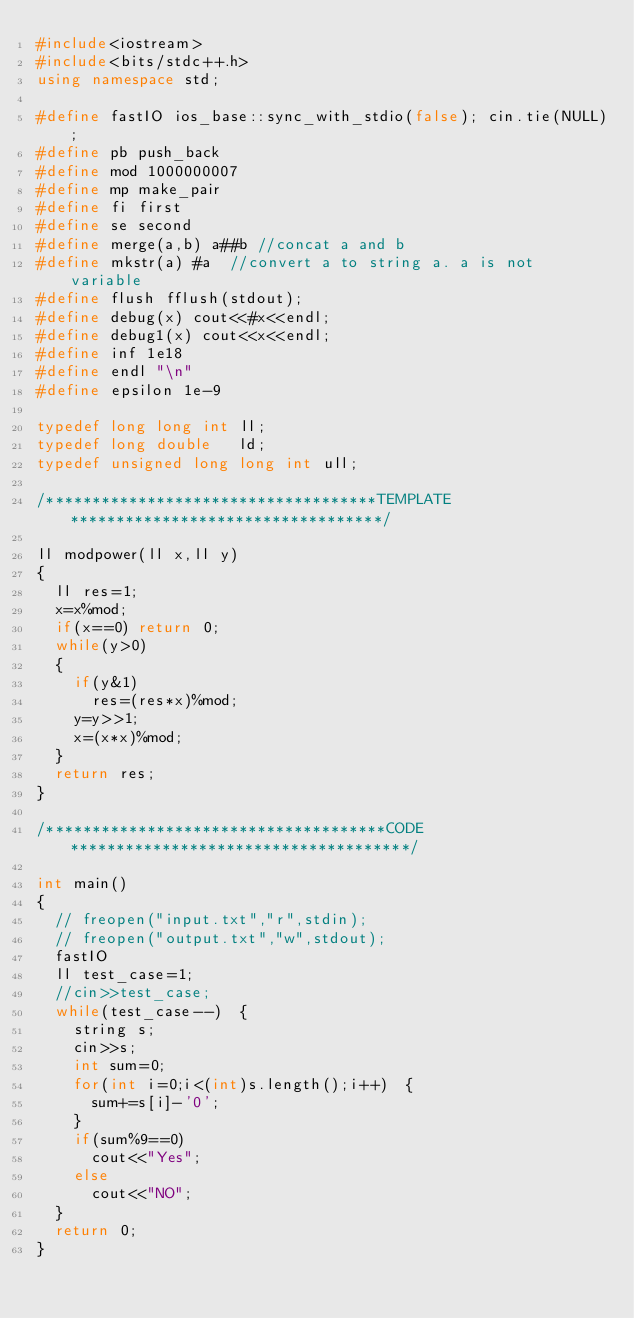<code> <loc_0><loc_0><loc_500><loc_500><_C++_>#include<iostream>
#include<bits/stdc++.h>
using namespace std;

#define fastIO ios_base::sync_with_stdio(false); cin.tie(NULL);
#define pb push_back
#define mod 1000000007
#define mp make_pair
#define fi first
#define se second
#define merge(a,b) a##b //concat a and b
#define mkstr(a) #a  //convert a to string a. a is not variable
#define flush fflush(stdout);
#define debug(x) cout<<#x<<endl;
#define debug1(x) cout<<x<<endl;
#define inf 1e18
#define endl "\n"
#define epsilon 1e-9

typedef long long int ll;
typedef long double   ld;
typedef unsigned long long int ull;

/************************************TEMPLATE**********************************/

ll modpower(ll x,ll y)
{
  ll res=1;
  x=x%mod;
  if(x==0) return 0;
  while(y>0)
  {
    if(y&1)
      res=(res*x)%mod;
    y=y>>1;
    x=(x*x)%mod;
  }
  return res;
}

/*************************************CODE*************************************/

int main()
{
  // freopen("input.txt","r",stdin);
  // freopen("output.txt","w",stdout);
  fastIO
  ll test_case=1;
  //cin>>test_case;
  while(test_case--)  {
    string s;
    cin>>s;
    int sum=0;
    for(int i=0;i<(int)s.length();i++)	{
    	sum+=s[i]-'0';
    }
    if(sum%9==0)
    	cout<<"Yes";
    else
    	cout<<"NO";
  }
  return 0;
}
</code> 